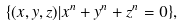Convert formula to latex. <formula><loc_0><loc_0><loc_500><loc_500>\{ ( x , y , z ) | x ^ { n } + y ^ { n } + z ^ { n } = 0 \} ,</formula> 